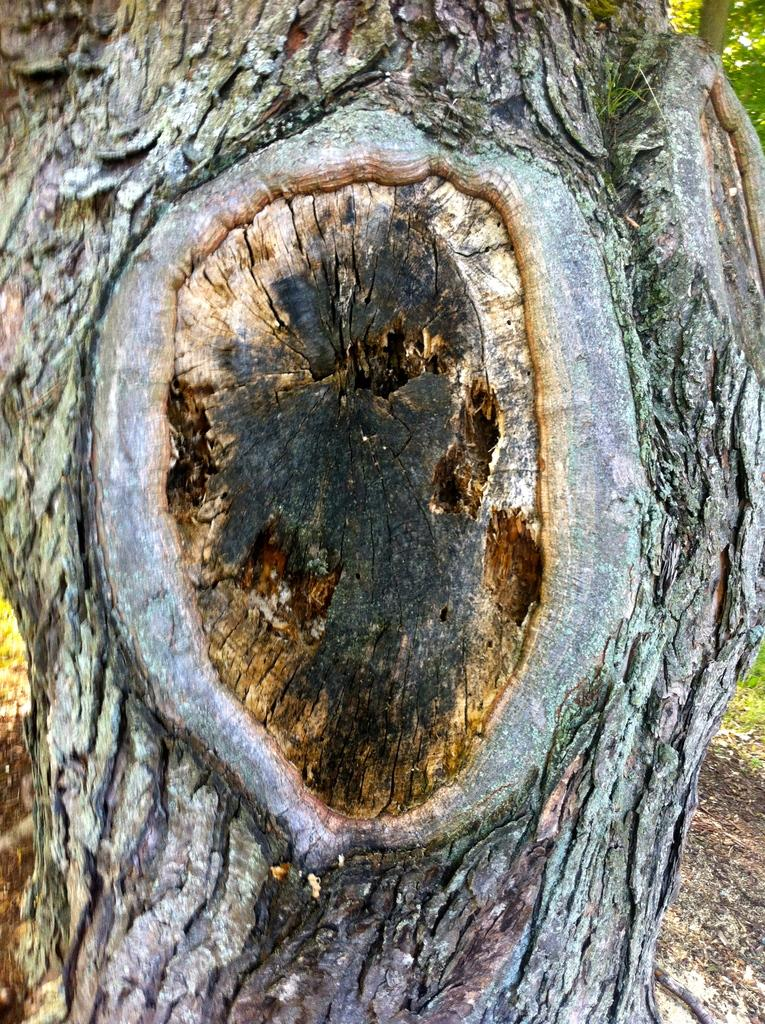What part of a tree is visible in the image? The trunk of a tree is visible in the image. What else can be seen on the tree in the image? There are leaves on the tree in the image. What is the surface beneath the tree in the image? The ground is visible in the image. What is the weight of the kitten sitting on the tree trunk in the image? There is no kitten present in the image, so it is not possible to determine its weight. 